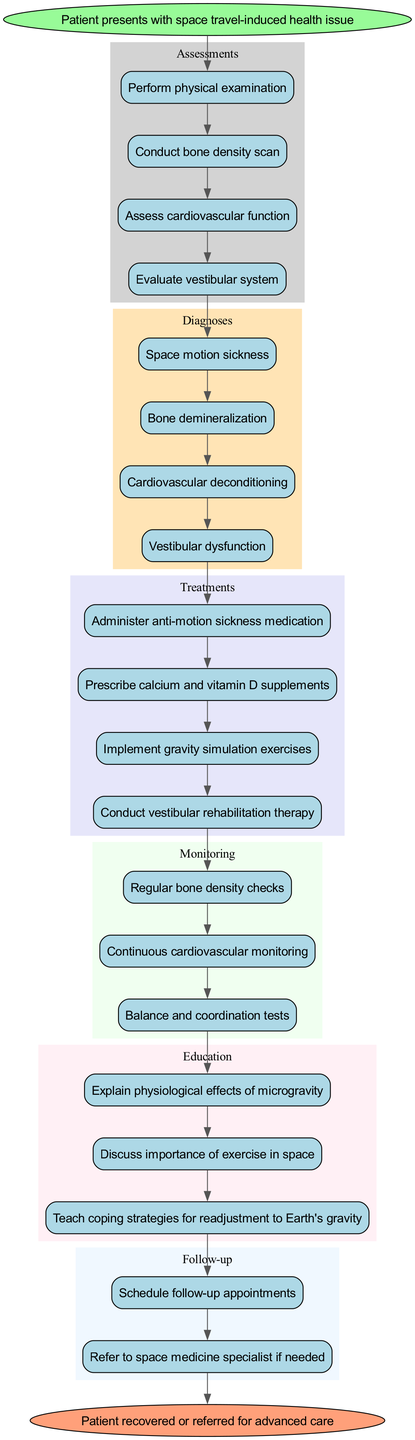What is the starting point in the clinical pathway? The starting point is indicated by the 'start' node in the diagram, which states "Patient presents with space travel-induced health issue."
Answer: Patient presents with space travel-induced health issue How many assessments are listed in the diagram? To find the number of assessments, count the nodes in the 'Assessments' cluster, which are four in total: "Perform physical examination," "Conduct bone density scan," "Assess cardiovascular function," and "Evaluate vestibular system."
Answer: 4 What is the last treatment mentioned in the pathway? The last treatment can be found by looking at the 'Treatments' cluster, where the treatments are listed sequentially, ending with "Conduct vestibular rehabilitation therapy."
Answer: Conduct vestibular rehabilitation therapy Which education topic directly follows the monitoring stage? The education topic immediately following the 'Monitoring' stage can be found by tracing the edge that connects the last monitoring node to the first education node, which discusses "Explain physiological effects of microgravity."
Answer: Explain physiological effects of microgravity What is the connection between treatment and monitoring? The connection is made by the directed edge that leads from the last treatment node to the first monitoring node, indicating that monitoring occurs after treatment has been implemented.
Answer: Treatment leads to monitoring How many follow-up actions are prescribed? By examining the 'Follow-up' cluster in the diagram, there are two actions mentioned: "Schedule follow-up appointments" and "Refer to space medicine specialist if needed."
Answer: 2 What are the physiological issues that require assessment? The physiological issues that require assessment, which are noted in the 'Assessments' section of the diagram, include "bone density," "cardiovascular function," and "vestibular system," among others.
Answer: bone density, cardiovascular function, vestibular system What is the outcome of the pathway when the patient is referred for advanced care? The end node of the clinical pathway indicates that the outcome is "Patient recovered or referred for advanced care," showing the final state based on the clinical decisions made through the pathway.
Answer: Patient recovered or referred for advanced care 